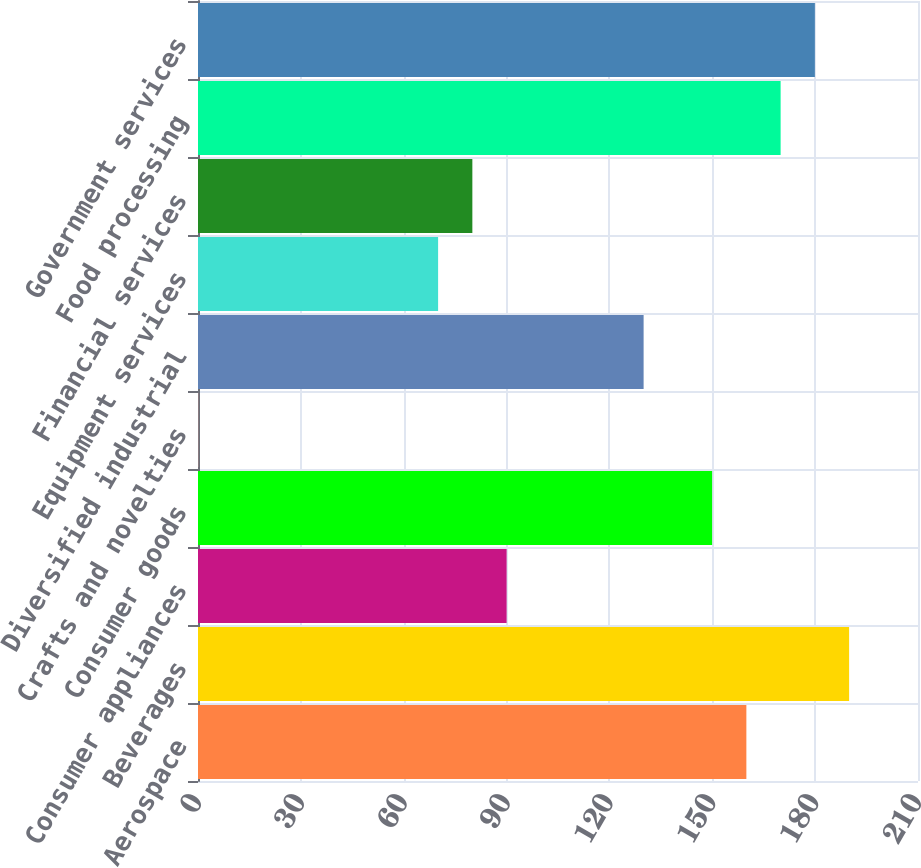Convert chart. <chart><loc_0><loc_0><loc_500><loc_500><bar_chart><fcel>Aerospace<fcel>Beverages<fcel>Consumer appliances<fcel>Consumer goods<fcel>Crafts and novelties<fcel>Diversified industrial<fcel>Equipment services<fcel>Financial services<fcel>Food processing<fcel>Government services<nl><fcel>159.94<fcel>189.91<fcel>90.01<fcel>149.95<fcel>0.1<fcel>129.97<fcel>70.03<fcel>80.02<fcel>169.93<fcel>179.92<nl></chart> 